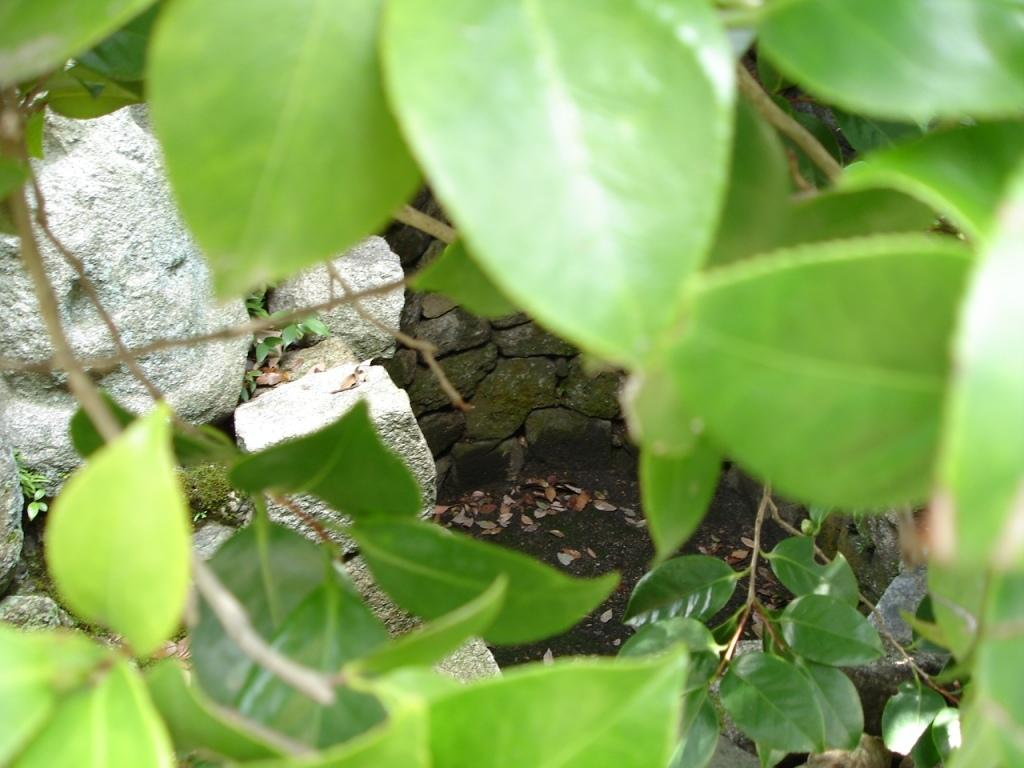What type of vegetation can be seen in the image? There are leaves in the image. What can be seen in the background of the image? There are stones in the background of the image. What news channel is being broadcasted on the leaves in the image? There is no news channel or any form of media present in the image; it features leaves and stones. 